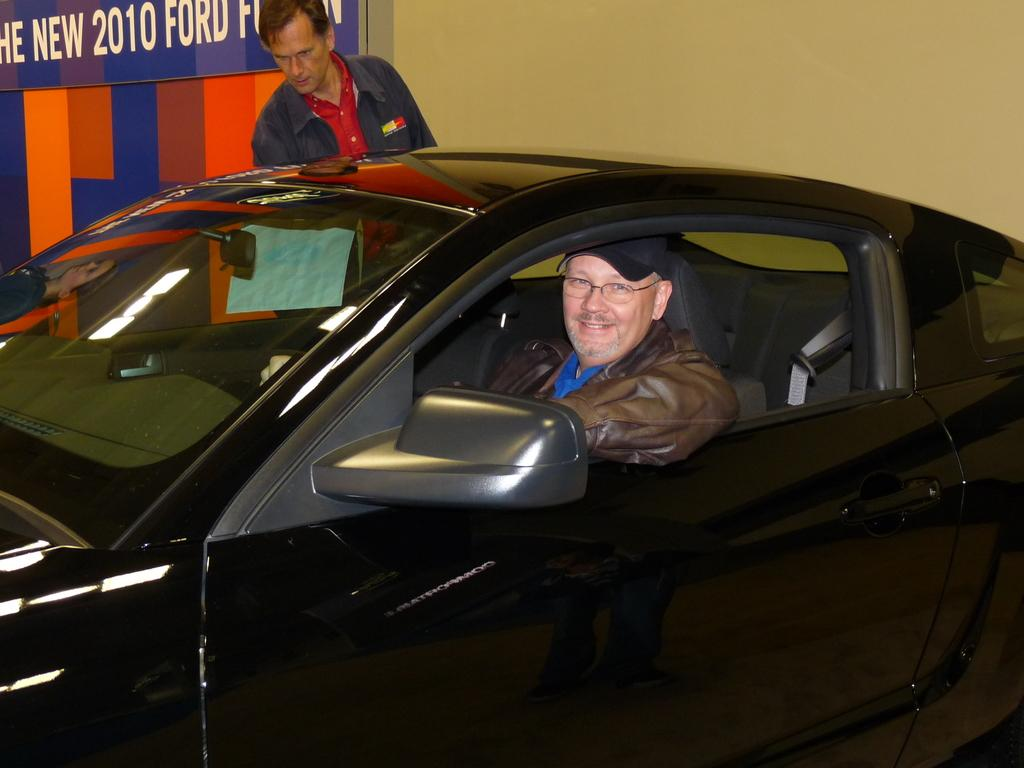How many people are in the image? There are two persons in the image. What are the positions of the two people in the image? One person is sitting inside a car, while the other person is standing behind the car. What can be seen at the back of the image? There is a hoarding at the back of the image. Are there any cactus plants visible in the image? No, there are no cactus plants present in the image. Can you see any dogs playing in the stream in the image? There is no stream or dogs present in the image. 